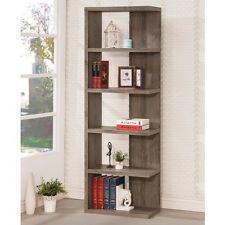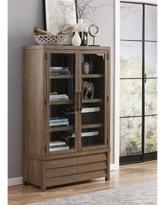The first image is the image on the left, the second image is the image on the right. Given the left and right images, does the statement "The shelves in the image on the left have no doors." hold true? Answer yes or no. Yes. The first image is the image on the left, the second image is the image on the right. For the images shown, is this caption "One image features a backless, sideless style of shelf storage in brown wood, and the other image features more traditional styling with glass-fronted enclosed white cabinets." true? Answer yes or no. No. 